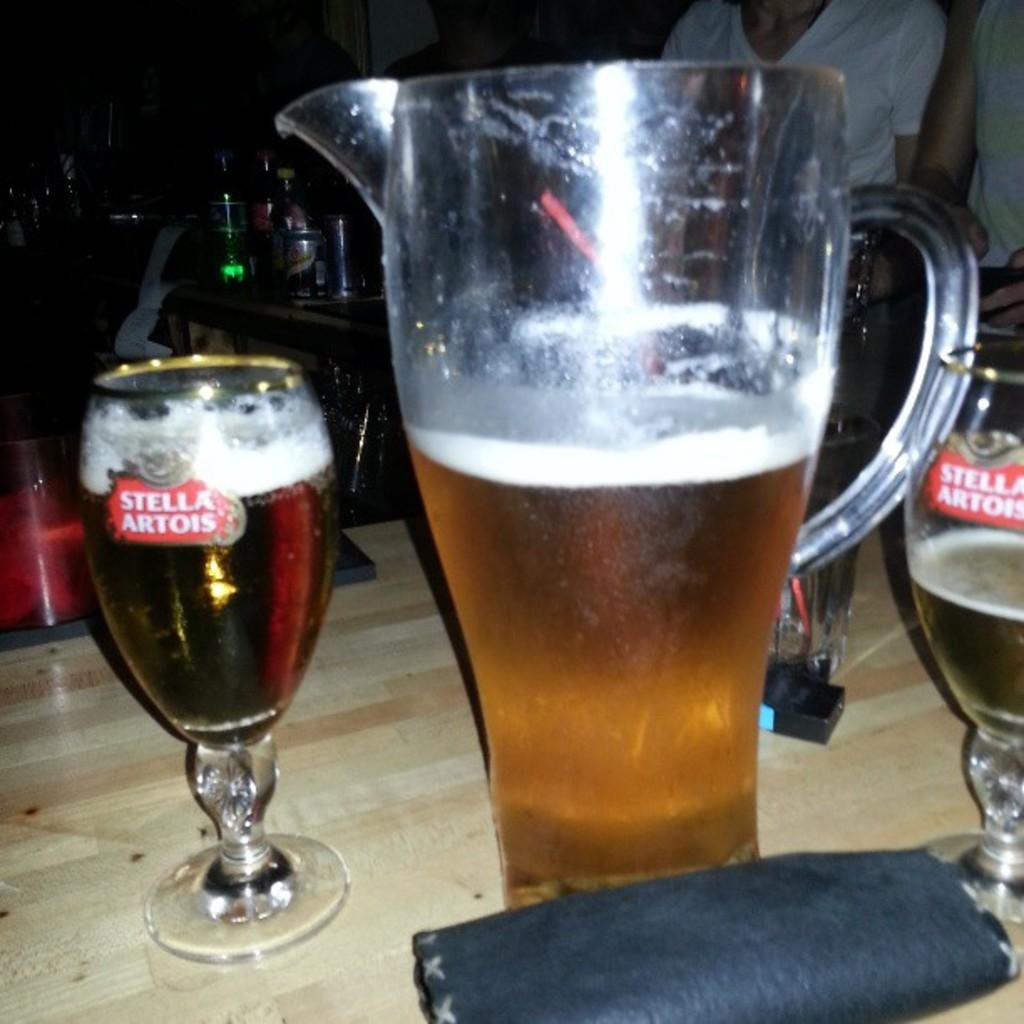<image>
Offer a succinct explanation of the picture presented. A pitcher and a glass of Stella Artois. 